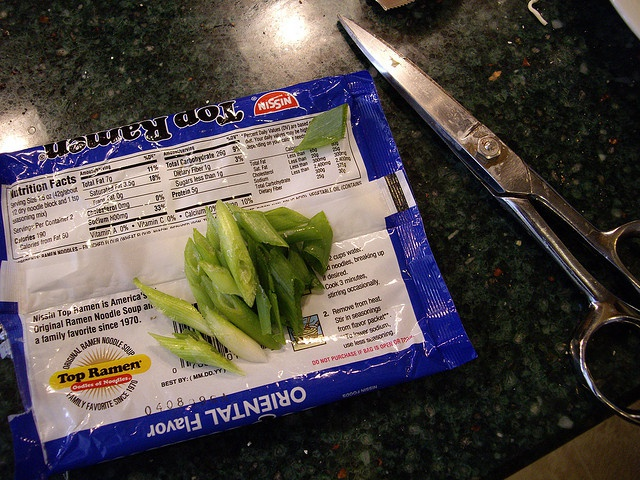Describe the objects in this image and their specific colors. I can see scissors in black, gray, and maroon tones in this image. 